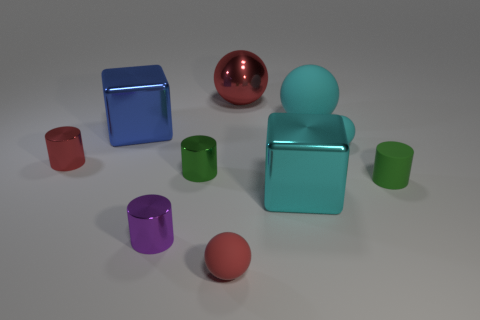How many objects are there in total, and can you categorize them by shape? There are a total of eight objects. They can be categorized by shape into four groups: two cylinders, three cubes, one sphere, and two toruses. Which objects stand out to you in terms of color vibrancy? The bright red cylinder and the vivid blue cube catch the eye with their vibrant hues. 